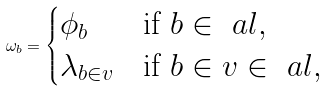<formula> <loc_0><loc_0><loc_500><loc_500>\omega _ { b } = \begin{cases} \phi _ { b } & \text {if } b \in \ a l , \\ \lambda _ { b \in v } & \text {if } b \in v \in \ a l , \end{cases}</formula> 